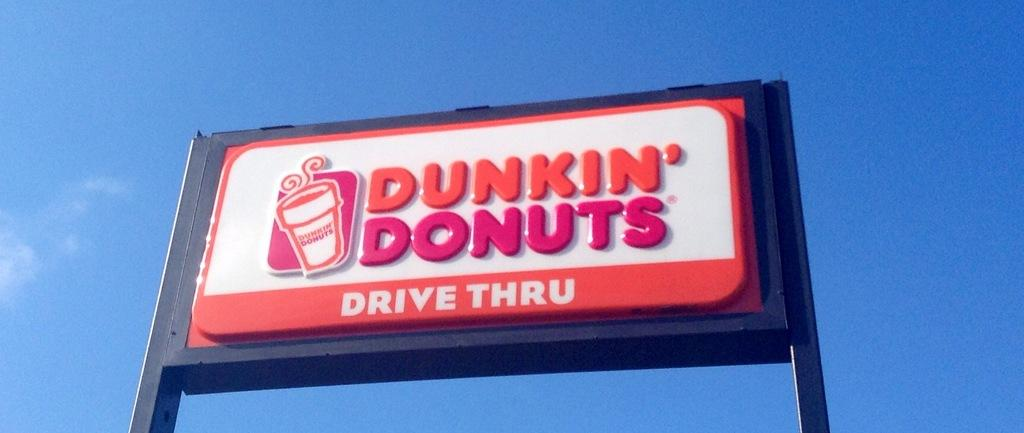<image>
Create a compact narrative representing the image presented. A Dunkin Donuts sign advertises a drive thru on a clear day. 